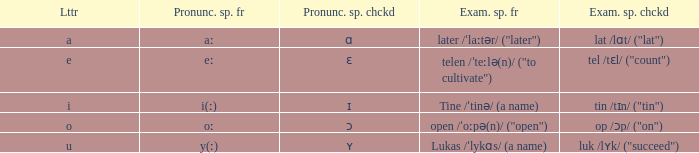What is Pronunciation Spelled Free, when Pronunciation Spelled Checked is "ʏ"? Y(ː). 